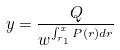Convert formula to latex. <formula><loc_0><loc_0><loc_500><loc_500>y = \frac { Q } { w ^ { \int _ { r _ { 1 } } ^ { x } P ( r ) d r } }</formula> 